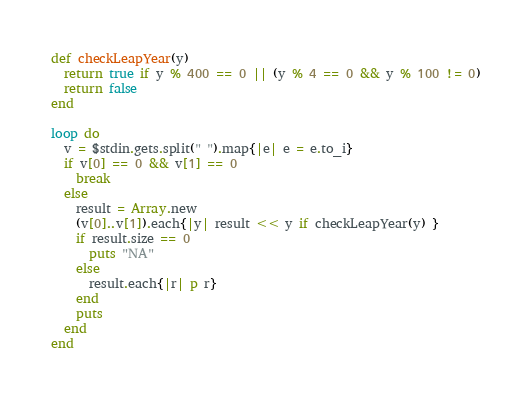Convert code to text. <code><loc_0><loc_0><loc_500><loc_500><_Ruby_>def checkLeapYear(y)
  return true if y % 400 == 0 || (y % 4 == 0 && y % 100 != 0)
  return false
end

loop do
  v = $stdin.gets.split(" ").map{|e| e = e.to_i}
  if v[0] == 0 && v[1] == 0
    break
  else
    result = Array.new
    (v[0]..v[1]).each{|y| result << y if checkLeapYear(y) }
    if result.size == 0
      puts "NA"
    else
      result.each{|r| p r}
    end
    puts
  end
end</code> 